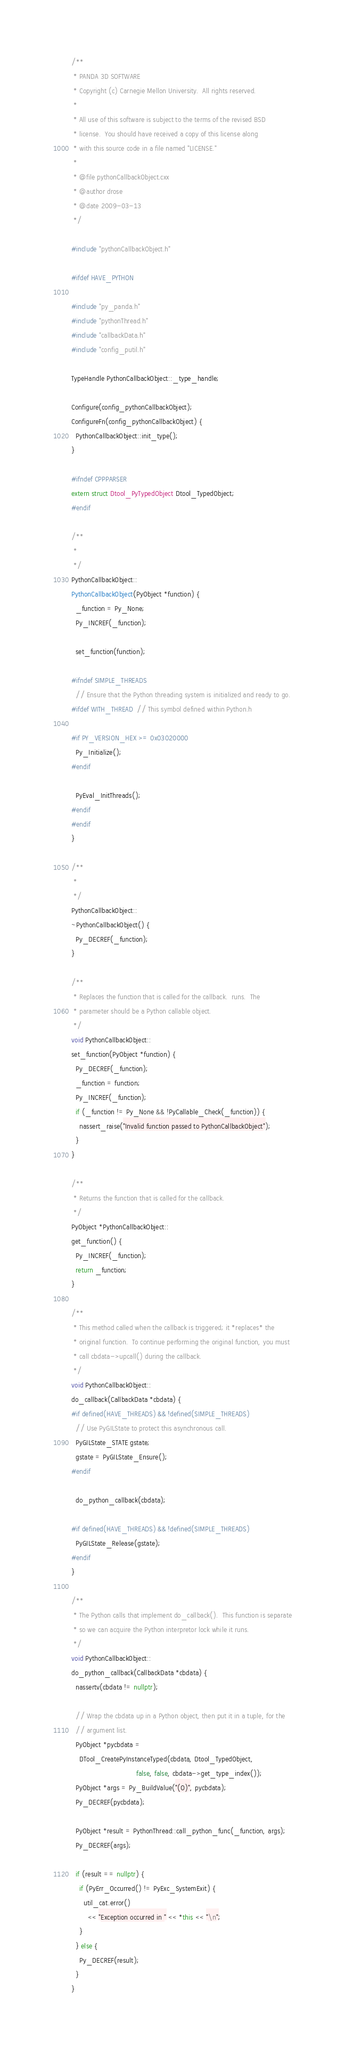<code> <loc_0><loc_0><loc_500><loc_500><_C++_>/**
 * PANDA 3D SOFTWARE
 * Copyright (c) Carnegie Mellon University.  All rights reserved.
 *
 * All use of this software is subject to the terms of the revised BSD
 * license.  You should have received a copy of this license along
 * with this source code in a file named "LICENSE."
 *
 * @file pythonCallbackObject.cxx
 * @author drose
 * @date 2009-03-13
 */

#include "pythonCallbackObject.h"

#ifdef HAVE_PYTHON

#include "py_panda.h"
#include "pythonThread.h"
#include "callbackData.h"
#include "config_putil.h"

TypeHandle PythonCallbackObject::_type_handle;

Configure(config_pythonCallbackObject);
ConfigureFn(config_pythonCallbackObject) {
  PythonCallbackObject::init_type();
}

#ifndef CPPPARSER
extern struct Dtool_PyTypedObject Dtool_TypedObject;
#endif

/**
 *
 */
PythonCallbackObject::
PythonCallbackObject(PyObject *function) {
  _function = Py_None;
  Py_INCREF(_function);

  set_function(function);

#ifndef SIMPLE_THREADS
  // Ensure that the Python threading system is initialized and ready to go.
#ifdef WITH_THREAD  // This symbol defined within Python.h

#if PY_VERSION_HEX >= 0x03020000
  Py_Initialize();
#endif

  PyEval_InitThreads();
#endif
#endif
}

/**
 *
 */
PythonCallbackObject::
~PythonCallbackObject() {
  Py_DECREF(_function);
}

/**
 * Replaces the function that is called for the callback.  runs.  The
 * parameter should be a Python callable object.
 */
void PythonCallbackObject::
set_function(PyObject *function) {
  Py_DECREF(_function);
  _function = function;
  Py_INCREF(_function);
  if (_function != Py_None && !PyCallable_Check(_function)) {
    nassert_raise("Invalid function passed to PythonCallbackObject");
  }
}

/**
 * Returns the function that is called for the callback.
 */
PyObject *PythonCallbackObject::
get_function() {
  Py_INCREF(_function);
  return _function;
}

/**
 * This method called when the callback is triggered; it *replaces* the
 * original function.  To continue performing the original function, you must
 * call cbdata->upcall() during the callback.
 */
void PythonCallbackObject::
do_callback(CallbackData *cbdata) {
#if defined(HAVE_THREADS) && !defined(SIMPLE_THREADS)
  // Use PyGILState to protect this asynchronous call.
  PyGILState_STATE gstate;
  gstate = PyGILState_Ensure();
#endif

  do_python_callback(cbdata);

#if defined(HAVE_THREADS) && !defined(SIMPLE_THREADS)
  PyGILState_Release(gstate);
#endif
}

/**
 * The Python calls that implement do_callback().  This function is separate
 * so we can acquire the Python interpretor lock while it runs.
 */
void PythonCallbackObject::
do_python_callback(CallbackData *cbdata) {
  nassertv(cbdata != nullptr);

  // Wrap the cbdata up in a Python object, then put it in a tuple, for the
  // argument list.
  PyObject *pycbdata =
    DTool_CreatePyInstanceTyped(cbdata, Dtool_TypedObject,
                                false, false, cbdata->get_type_index());
  PyObject *args = Py_BuildValue("(O)", pycbdata);
  Py_DECREF(pycbdata);

  PyObject *result = PythonThread::call_python_func(_function, args);
  Py_DECREF(args);

  if (result == nullptr) {
    if (PyErr_Occurred() != PyExc_SystemExit) {
      util_cat.error()
        << "Exception occurred in " << *this << "\n";
    }
  } else {
    Py_DECREF(result);
  }
}
</code> 